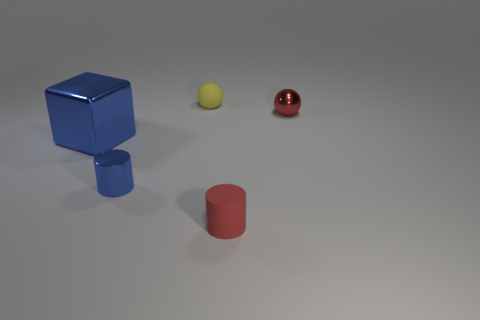Add 3 small gray rubber balls. How many objects exist? 8 Subtract 1 blocks. How many blocks are left? 0 Subtract all yellow balls. How many balls are left? 1 Subtract all cylinders. How many objects are left? 3 Add 4 big shiny objects. How many big shiny objects are left? 5 Add 1 small shiny spheres. How many small shiny spheres exist? 2 Subtract 1 red cylinders. How many objects are left? 4 Subtract all purple cubes. Subtract all purple cylinders. How many cubes are left? 1 Subtract all tiny shiny cylinders. Subtract all tiny green metal things. How many objects are left? 4 